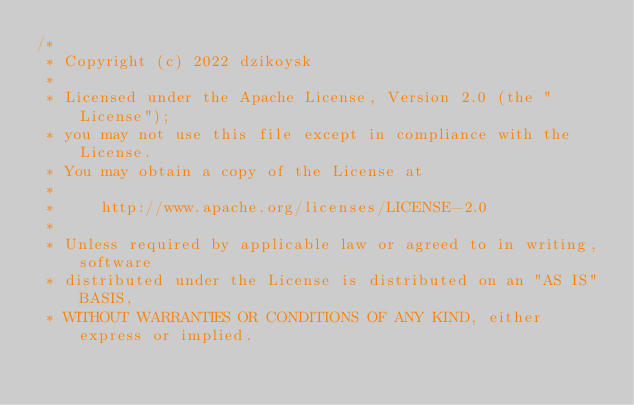<code> <loc_0><loc_0><loc_500><loc_500><_Kotlin_>/*
 * Copyright (c) 2022 dzikoysk
 *
 * Licensed under the Apache License, Version 2.0 (the "License");
 * you may not use this file except in compliance with the License.
 * You may obtain a copy of the License at
 *
 *     http://www.apache.org/licenses/LICENSE-2.0
 *
 * Unless required by applicable law or agreed to in writing, software
 * distributed under the License is distributed on an "AS IS" BASIS,
 * WITHOUT WARRANTIES OR CONDITIONS OF ANY KIND, either express or implied.</code> 